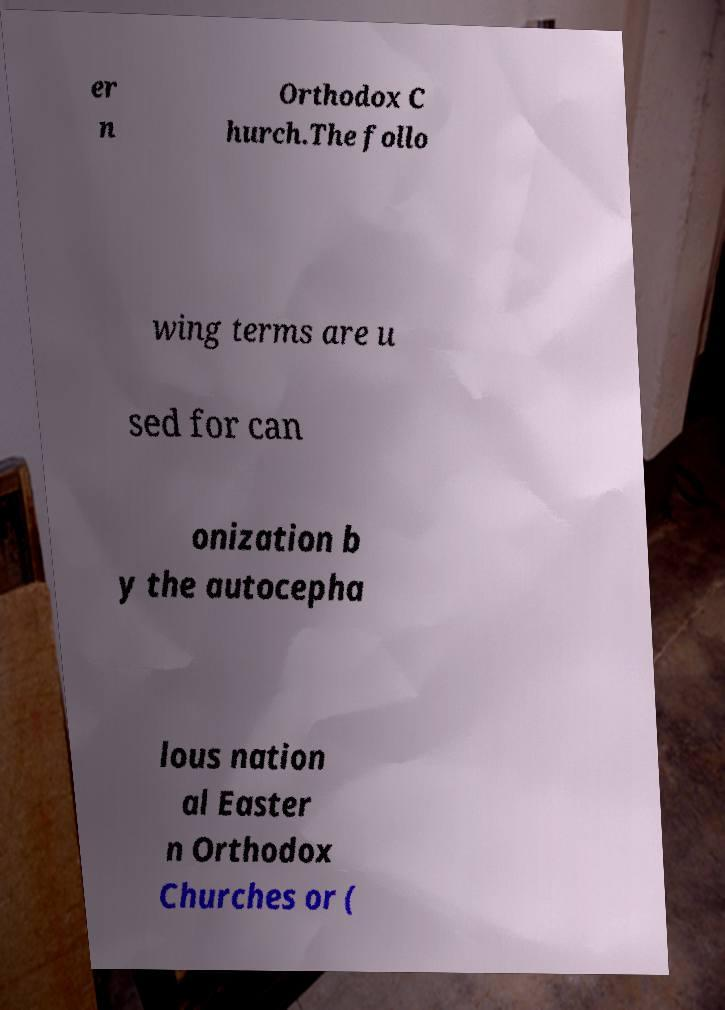What messages or text are displayed in this image? I need them in a readable, typed format. er n Orthodox C hurch.The follo wing terms are u sed for can onization b y the autocepha lous nation al Easter n Orthodox Churches or ( 